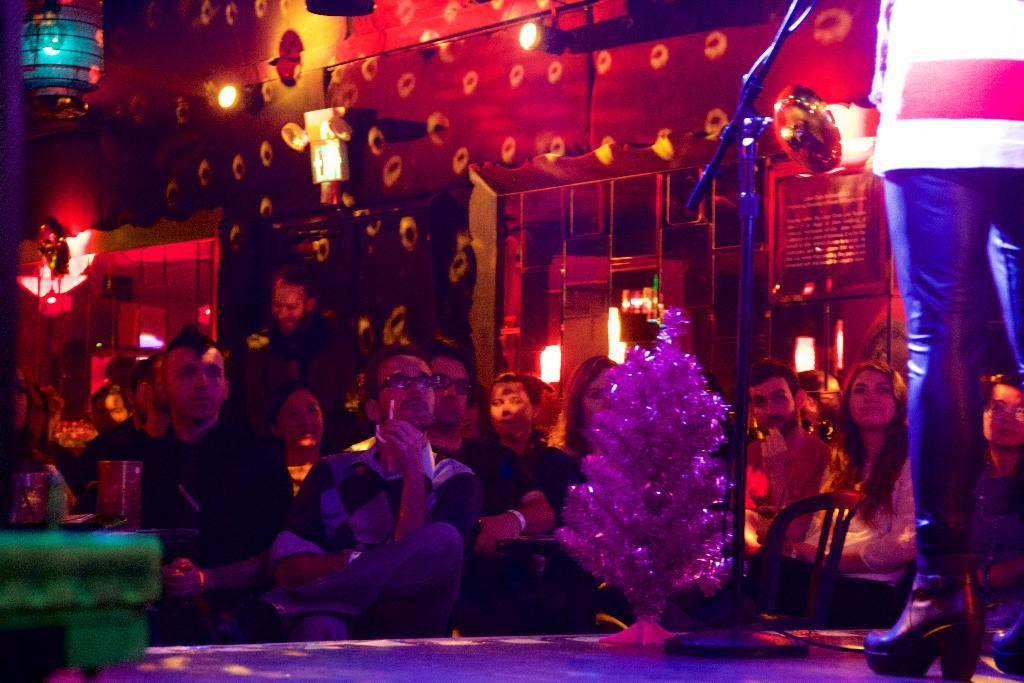What are the people in the image doing? The people in the image are seated on chairs. What might be the reason for the people being seated in the image? The people are watching a performance. Where is the performance taking place? The performance is happening on a stage. Who is performing in the image? There is a person on a stage performing. Can you tell me how many geese are on the stage during the performance? There are no geese present on the stage during the performance; only a person is performing. What type of game is being played by the people in the image? There is no game being played by the people in the image; they are watching a performance. 